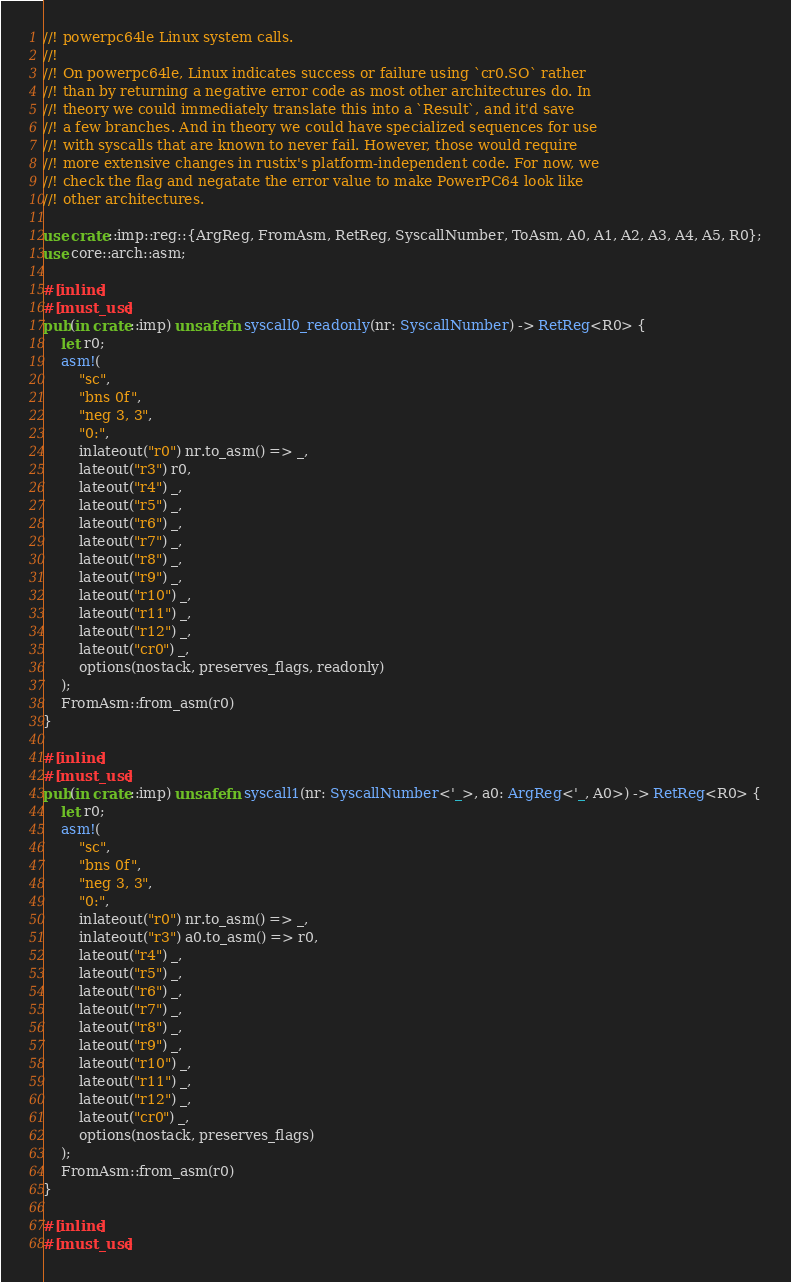Convert code to text. <code><loc_0><loc_0><loc_500><loc_500><_Rust_>//! powerpc64le Linux system calls.
//!
//! On powerpc64le, Linux indicates success or failure using `cr0.SO` rather
//! than by returning a negative error code as most other architectures do. In
//! theory we could immediately translate this into a `Result`, and it'd save
//! a few branches. And in theory we could have specialized sequences for use
//! with syscalls that are known to never fail. However, those would require
//! more extensive changes in rustix's platform-independent code. For now, we
//! check the flag and negatate the error value to make PowerPC64 look like
//! other architectures.

use crate::imp::reg::{ArgReg, FromAsm, RetReg, SyscallNumber, ToAsm, A0, A1, A2, A3, A4, A5, R0};
use core::arch::asm;

#[inline]
#[must_use]
pub(in crate::imp) unsafe fn syscall0_readonly(nr: SyscallNumber) -> RetReg<R0> {
    let r0;
    asm!(
        "sc",
        "bns 0f",
        "neg 3, 3",
        "0:",
        inlateout("r0") nr.to_asm() => _,
        lateout("r3") r0,
        lateout("r4") _,
        lateout("r5") _,
        lateout("r6") _,
        lateout("r7") _,
        lateout("r8") _,
        lateout("r9") _,
        lateout("r10") _,
        lateout("r11") _,
        lateout("r12") _,
        lateout("cr0") _,
        options(nostack, preserves_flags, readonly)
    );
    FromAsm::from_asm(r0)
}

#[inline]
#[must_use]
pub(in crate::imp) unsafe fn syscall1(nr: SyscallNumber<'_>, a0: ArgReg<'_, A0>) -> RetReg<R0> {
    let r0;
    asm!(
        "sc",
        "bns 0f",
        "neg 3, 3",
        "0:",
        inlateout("r0") nr.to_asm() => _,
        inlateout("r3") a0.to_asm() => r0,
        lateout("r4") _,
        lateout("r5") _,
        lateout("r6") _,
        lateout("r7") _,
        lateout("r8") _,
        lateout("r9") _,
        lateout("r10") _,
        lateout("r11") _,
        lateout("r12") _,
        lateout("cr0") _,
        options(nostack, preserves_flags)
    );
    FromAsm::from_asm(r0)
}

#[inline]
#[must_use]</code> 